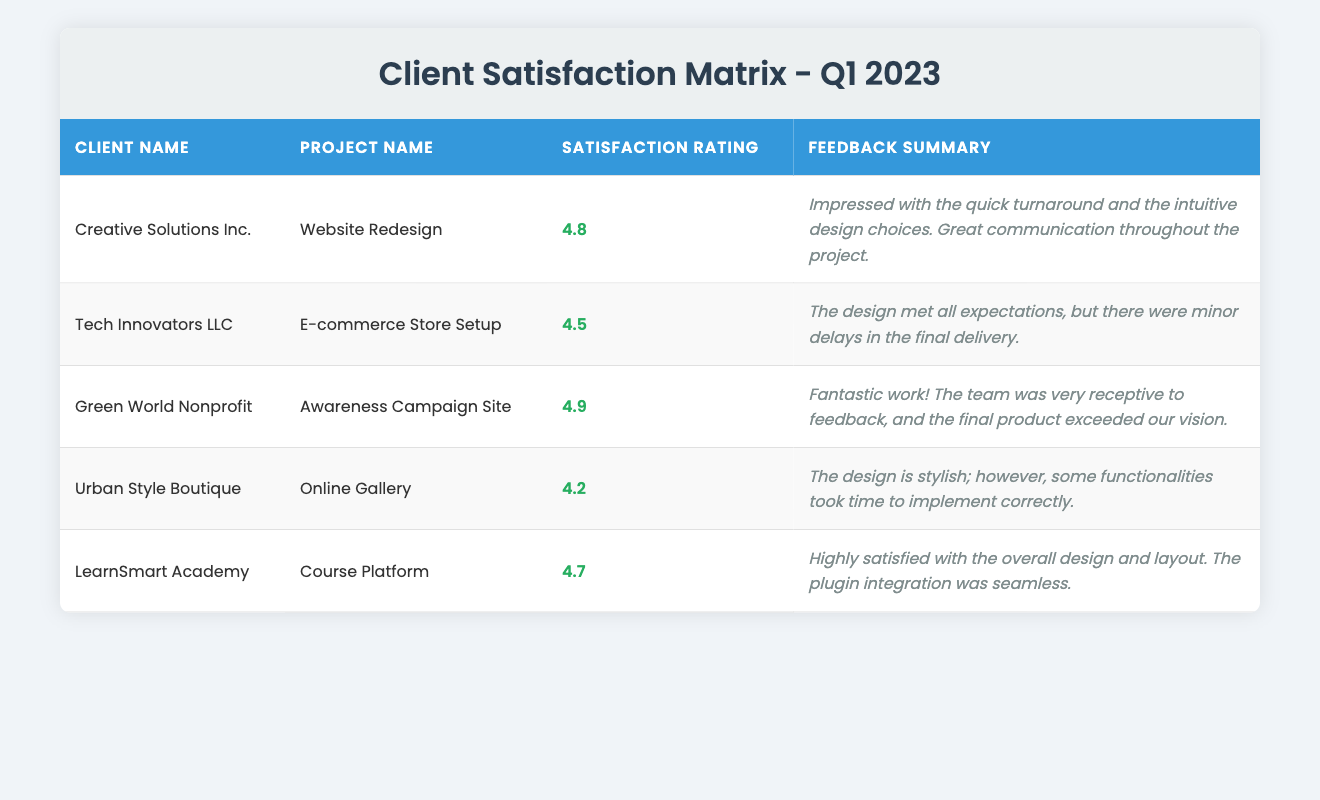What is the satisfaction rating for Green World Nonprofit? The satisfaction rating for Green World Nonprofit is listed directly in the table under the "Satisfaction Rating" column. It shows 4.9.
Answer: 4.9 Which project received the lowest satisfaction rating? By looking at the "Satisfaction Rating" column, the lowest rating is 4.2, which corresponds to the project "Online Gallery" by Urban Style Boutique.
Answer: Online Gallery What is the average satisfaction rating across all projects? To find the average, add all satisfaction ratings: 4.8 + 4.5 + 4.9 + 4.2 + 4.7 = 24.1. Then divide by the number of projects, which is 5: 24.1 / 5 = 4.82.
Answer: 4.82 Did any client express dissatisfaction with the design? None of the feedback summaries mention dissatisfaction; they all highlight positive aspects or minor issues. Therefore, the statement is false.
Answer: No Who provided feedback mentioning "fantastic work"? The feedback "Fantastic work! The team was very receptive to feedback, and the final product exceeded our vision." comes from Green World Nonprofit as per their feedback summary in the table.
Answer: Green World Nonprofit What were the main concerns of Urban Style Boutique regarding their project? Urban Style Boutique's feedback summary mentions that the design is stylish, but some functionalities took time to implement correctly. This indicates their main concern was about the functionality implementation.
Answer: Functionality implementation How many clients rated their satisfaction above 4.5? Clients with satisfaction ratings above 4.5 are Creative Solutions Inc. (4.8), Green World Nonprofit (4.9), and LearnSmart Academy (4.7). Counting these, there are 3 clients.
Answer: 3 Was there any client who reported a quick turnaround time? Yes, Creative Solutions Inc. mentioned being "impressed with the quick turnaround" in their feedback summary.
Answer: Yes Which project had minor delays in the final delivery? The project "E-commerce Store Setup" by Tech Innovators LLC reported minor delays in the final delivery according to the feedback summary column.
Answer: E-commerce Store Setup 